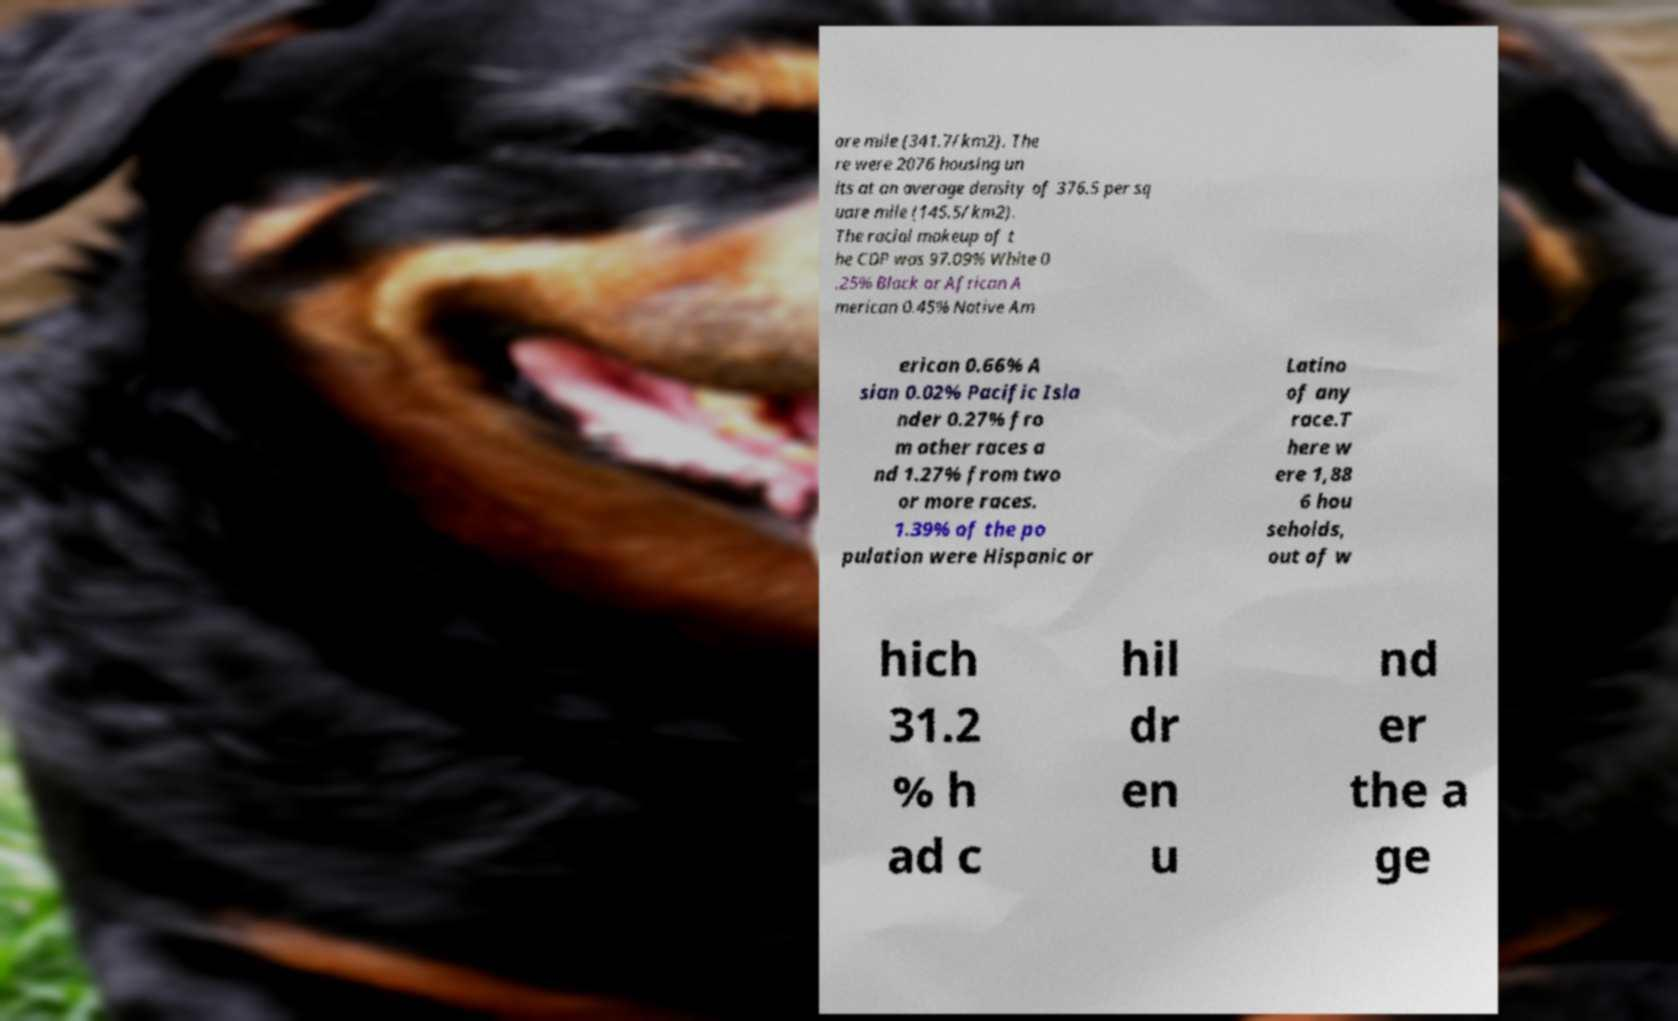Please read and relay the text visible in this image. What does it say? are mile (341.7/km2). The re were 2076 housing un its at an average density of 376.5 per sq uare mile (145.5/km2). The racial makeup of t he CDP was 97.09% White 0 .25% Black or African A merican 0.45% Native Am erican 0.66% A sian 0.02% Pacific Isla nder 0.27% fro m other races a nd 1.27% from two or more races. 1.39% of the po pulation were Hispanic or Latino of any race.T here w ere 1,88 6 hou seholds, out of w hich 31.2 % h ad c hil dr en u nd er the a ge 